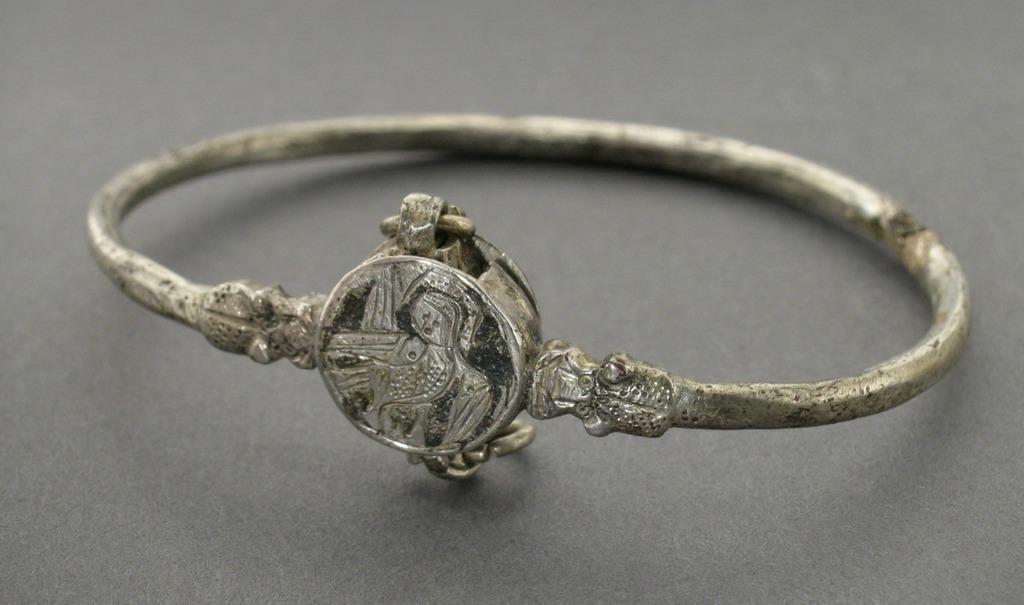Could you give a brief overview of what you see in this image? In this image I can see a ring on a black surface. 